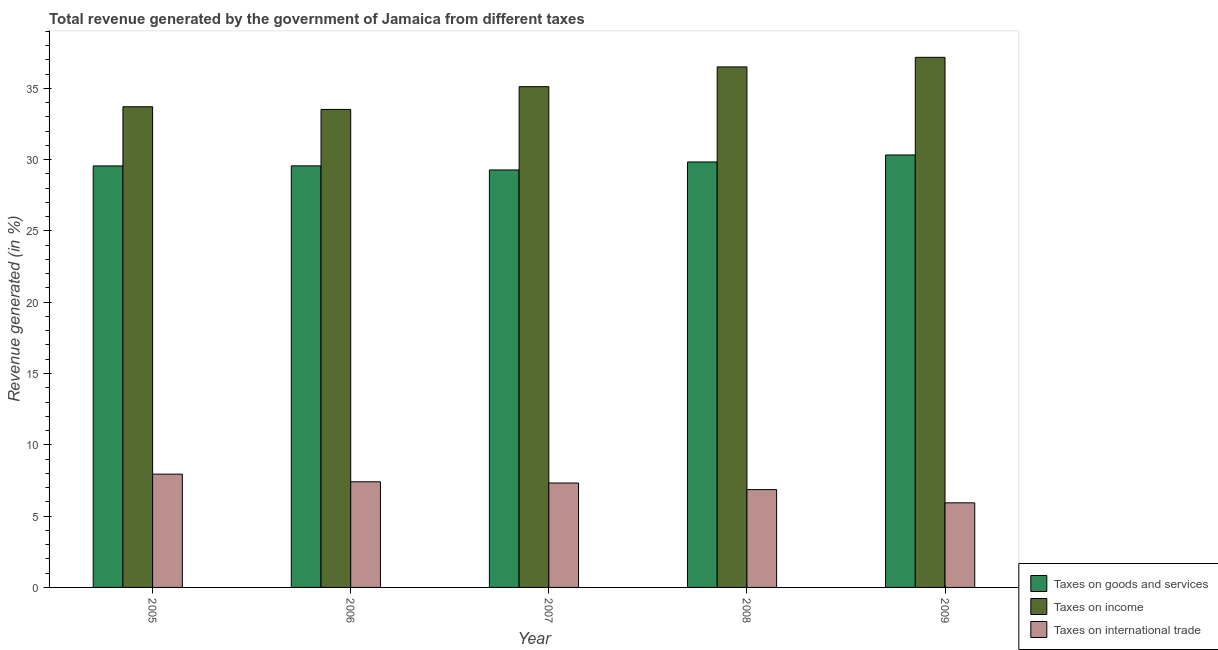How many different coloured bars are there?
Keep it short and to the point. 3. Are the number of bars per tick equal to the number of legend labels?
Give a very brief answer. Yes. Are the number of bars on each tick of the X-axis equal?
Keep it short and to the point. Yes. What is the label of the 3rd group of bars from the left?
Keep it short and to the point. 2007. What is the percentage of revenue generated by taxes on goods and services in 2009?
Offer a very short reply. 30.32. Across all years, what is the maximum percentage of revenue generated by tax on international trade?
Give a very brief answer. 7.94. Across all years, what is the minimum percentage of revenue generated by taxes on goods and services?
Your answer should be very brief. 29.27. In which year was the percentage of revenue generated by taxes on income maximum?
Your response must be concise. 2009. In which year was the percentage of revenue generated by taxes on income minimum?
Your answer should be very brief. 2006. What is the total percentage of revenue generated by taxes on income in the graph?
Your answer should be compact. 176. What is the difference between the percentage of revenue generated by tax on international trade in 2006 and that in 2007?
Your answer should be very brief. 0.08. What is the difference between the percentage of revenue generated by tax on international trade in 2007 and the percentage of revenue generated by taxes on goods and services in 2008?
Provide a succinct answer. 0.46. What is the average percentage of revenue generated by taxes on goods and services per year?
Your response must be concise. 29.71. What is the ratio of the percentage of revenue generated by taxes on goods and services in 2006 to that in 2007?
Your answer should be compact. 1.01. What is the difference between the highest and the second highest percentage of revenue generated by taxes on income?
Your answer should be very brief. 0.67. What is the difference between the highest and the lowest percentage of revenue generated by taxes on income?
Provide a succinct answer. 3.65. In how many years, is the percentage of revenue generated by taxes on goods and services greater than the average percentage of revenue generated by taxes on goods and services taken over all years?
Your response must be concise. 2. Is the sum of the percentage of revenue generated by tax on international trade in 2006 and 2007 greater than the maximum percentage of revenue generated by taxes on income across all years?
Provide a succinct answer. Yes. What does the 1st bar from the left in 2009 represents?
Ensure brevity in your answer.  Taxes on goods and services. What does the 1st bar from the right in 2005 represents?
Your response must be concise. Taxes on international trade. How many bars are there?
Your answer should be very brief. 15. Are all the bars in the graph horizontal?
Offer a very short reply. No. What is the difference between two consecutive major ticks on the Y-axis?
Offer a terse response. 5. Are the values on the major ticks of Y-axis written in scientific E-notation?
Provide a succinct answer. No. Where does the legend appear in the graph?
Ensure brevity in your answer.  Bottom right. How many legend labels are there?
Offer a terse response. 3. What is the title of the graph?
Provide a succinct answer. Total revenue generated by the government of Jamaica from different taxes. What is the label or title of the X-axis?
Keep it short and to the point. Year. What is the label or title of the Y-axis?
Offer a very short reply. Revenue generated (in %). What is the Revenue generated (in %) of Taxes on goods and services in 2005?
Give a very brief answer. 29.55. What is the Revenue generated (in %) of Taxes on income in 2005?
Ensure brevity in your answer.  33.7. What is the Revenue generated (in %) in Taxes on international trade in 2005?
Provide a short and direct response. 7.94. What is the Revenue generated (in %) in Taxes on goods and services in 2006?
Your response must be concise. 29.56. What is the Revenue generated (in %) in Taxes on income in 2006?
Keep it short and to the point. 33.52. What is the Revenue generated (in %) in Taxes on international trade in 2006?
Provide a succinct answer. 7.41. What is the Revenue generated (in %) of Taxes on goods and services in 2007?
Your response must be concise. 29.27. What is the Revenue generated (in %) of Taxes on income in 2007?
Give a very brief answer. 35.11. What is the Revenue generated (in %) in Taxes on international trade in 2007?
Make the answer very short. 7.32. What is the Revenue generated (in %) in Taxes on goods and services in 2008?
Offer a terse response. 29.83. What is the Revenue generated (in %) in Taxes on income in 2008?
Make the answer very short. 36.5. What is the Revenue generated (in %) of Taxes on international trade in 2008?
Your answer should be compact. 6.86. What is the Revenue generated (in %) in Taxes on goods and services in 2009?
Offer a terse response. 30.32. What is the Revenue generated (in %) in Taxes on income in 2009?
Make the answer very short. 37.17. What is the Revenue generated (in %) in Taxes on international trade in 2009?
Offer a very short reply. 5.93. Across all years, what is the maximum Revenue generated (in %) of Taxes on goods and services?
Offer a very short reply. 30.32. Across all years, what is the maximum Revenue generated (in %) of Taxes on income?
Your answer should be very brief. 37.17. Across all years, what is the maximum Revenue generated (in %) of Taxes on international trade?
Make the answer very short. 7.94. Across all years, what is the minimum Revenue generated (in %) in Taxes on goods and services?
Provide a short and direct response. 29.27. Across all years, what is the minimum Revenue generated (in %) in Taxes on income?
Keep it short and to the point. 33.52. Across all years, what is the minimum Revenue generated (in %) in Taxes on international trade?
Your answer should be compact. 5.93. What is the total Revenue generated (in %) in Taxes on goods and services in the graph?
Your answer should be compact. 148.54. What is the total Revenue generated (in %) of Taxes on income in the graph?
Make the answer very short. 176. What is the total Revenue generated (in %) in Taxes on international trade in the graph?
Your answer should be very brief. 35.46. What is the difference between the Revenue generated (in %) in Taxes on goods and services in 2005 and that in 2006?
Provide a succinct answer. -0. What is the difference between the Revenue generated (in %) in Taxes on income in 2005 and that in 2006?
Your answer should be very brief. 0.19. What is the difference between the Revenue generated (in %) in Taxes on international trade in 2005 and that in 2006?
Your answer should be very brief. 0.54. What is the difference between the Revenue generated (in %) of Taxes on goods and services in 2005 and that in 2007?
Give a very brief answer. 0.28. What is the difference between the Revenue generated (in %) in Taxes on income in 2005 and that in 2007?
Provide a short and direct response. -1.41. What is the difference between the Revenue generated (in %) of Taxes on international trade in 2005 and that in 2007?
Your answer should be very brief. 0.62. What is the difference between the Revenue generated (in %) of Taxes on goods and services in 2005 and that in 2008?
Offer a terse response. -0.28. What is the difference between the Revenue generated (in %) in Taxes on income in 2005 and that in 2008?
Provide a short and direct response. -2.79. What is the difference between the Revenue generated (in %) of Taxes on international trade in 2005 and that in 2008?
Keep it short and to the point. 1.09. What is the difference between the Revenue generated (in %) of Taxes on goods and services in 2005 and that in 2009?
Keep it short and to the point. -0.77. What is the difference between the Revenue generated (in %) of Taxes on income in 2005 and that in 2009?
Make the answer very short. -3.47. What is the difference between the Revenue generated (in %) in Taxes on international trade in 2005 and that in 2009?
Keep it short and to the point. 2.01. What is the difference between the Revenue generated (in %) in Taxes on goods and services in 2006 and that in 2007?
Offer a terse response. 0.28. What is the difference between the Revenue generated (in %) of Taxes on income in 2006 and that in 2007?
Offer a terse response. -1.6. What is the difference between the Revenue generated (in %) in Taxes on international trade in 2006 and that in 2007?
Give a very brief answer. 0.08. What is the difference between the Revenue generated (in %) in Taxes on goods and services in 2006 and that in 2008?
Offer a terse response. -0.28. What is the difference between the Revenue generated (in %) in Taxes on income in 2006 and that in 2008?
Give a very brief answer. -2.98. What is the difference between the Revenue generated (in %) in Taxes on international trade in 2006 and that in 2008?
Offer a very short reply. 0.55. What is the difference between the Revenue generated (in %) of Taxes on goods and services in 2006 and that in 2009?
Give a very brief answer. -0.77. What is the difference between the Revenue generated (in %) of Taxes on income in 2006 and that in 2009?
Offer a very short reply. -3.65. What is the difference between the Revenue generated (in %) of Taxes on international trade in 2006 and that in 2009?
Ensure brevity in your answer.  1.48. What is the difference between the Revenue generated (in %) in Taxes on goods and services in 2007 and that in 2008?
Provide a short and direct response. -0.56. What is the difference between the Revenue generated (in %) of Taxes on income in 2007 and that in 2008?
Your response must be concise. -1.38. What is the difference between the Revenue generated (in %) in Taxes on international trade in 2007 and that in 2008?
Offer a terse response. 0.46. What is the difference between the Revenue generated (in %) of Taxes on goods and services in 2007 and that in 2009?
Make the answer very short. -1.05. What is the difference between the Revenue generated (in %) of Taxes on income in 2007 and that in 2009?
Your answer should be compact. -2.06. What is the difference between the Revenue generated (in %) in Taxes on international trade in 2007 and that in 2009?
Your response must be concise. 1.39. What is the difference between the Revenue generated (in %) in Taxes on goods and services in 2008 and that in 2009?
Your response must be concise. -0.49. What is the difference between the Revenue generated (in %) of Taxes on income in 2008 and that in 2009?
Your answer should be compact. -0.67. What is the difference between the Revenue generated (in %) of Taxes on international trade in 2008 and that in 2009?
Your response must be concise. 0.93. What is the difference between the Revenue generated (in %) of Taxes on goods and services in 2005 and the Revenue generated (in %) of Taxes on income in 2006?
Give a very brief answer. -3.96. What is the difference between the Revenue generated (in %) of Taxes on goods and services in 2005 and the Revenue generated (in %) of Taxes on international trade in 2006?
Give a very brief answer. 22.15. What is the difference between the Revenue generated (in %) in Taxes on income in 2005 and the Revenue generated (in %) in Taxes on international trade in 2006?
Offer a terse response. 26.3. What is the difference between the Revenue generated (in %) in Taxes on goods and services in 2005 and the Revenue generated (in %) in Taxes on income in 2007?
Your answer should be compact. -5.56. What is the difference between the Revenue generated (in %) in Taxes on goods and services in 2005 and the Revenue generated (in %) in Taxes on international trade in 2007?
Keep it short and to the point. 22.23. What is the difference between the Revenue generated (in %) of Taxes on income in 2005 and the Revenue generated (in %) of Taxes on international trade in 2007?
Ensure brevity in your answer.  26.38. What is the difference between the Revenue generated (in %) of Taxes on goods and services in 2005 and the Revenue generated (in %) of Taxes on income in 2008?
Ensure brevity in your answer.  -6.94. What is the difference between the Revenue generated (in %) of Taxes on goods and services in 2005 and the Revenue generated (in %) of Taxes on international trade in 2008?
Give a very brief answer. 22.7. What is the difference between the Revenue generated (in %) of Taxes on income in 2005 and the Revenue generated (in %) of Taxes on international trade in 2008?
Keep it short and to the point. 26.84. What is the difference between the Revenue generated (in %) of Taxes on goods and services in 2005 and the Revenue generated (in %) of Taxes on income in 2009?
Ensure brevity in your answer.  -7.61. What is the difference between the Revenue generated (in %) in Taxes on goods and services in 2005 and the Revenue generated (in %) in Taxes on international trade in 2009?
Provide a short and direct response. 23.62. What is the difference between the Revenue generated (in %) of Taxes on income in 2005 and the Revenue generated (in %) of Taxes on international trade in 2009?
Offer a very short reply. 27.77. What is the difference between the Revenue generated (in %) of Taxes on goods and services in 2006 and the Revenue generated (in %) of Taxes on income in 2007?
Give a very brief answer. -5.56. What is the difference between the Revenue generated (in %) in Taxes on goods and services in 2006 and the Revenue generated (in %) in Taxes on international trade in 2007?
Offer a very short reply. 22.23. What is the difference between the Revenue generated (in %) in Taxes on income in 2006 and the Revenue generated (in %) in Taxes on international trade in 2007?
Provide a succinct answer. 26.19. What is the difference between the Revenue generated (in %) in Taxes on goods and services in 2006 and the Revenue generated (in %) in Taxes on income in 2008?
Your response must be concise. -6.94. What is the difference between the Revenue generated (in %) in Taxes on goods and services in 2006 and the Revenue generated (in %) in Taxes on international trade in 2008?
Provide a succinct answer. 22.7. What is the difference between the Revenue generated (in %) of Taxes on income in 2006 and the Revenue generated (in %) of Taxes on international trade in 2008?
Your answer should be very brief. 26.66. What is the difference between the Revenue generated (in %) of Taxes on goods and services in 2006 and the Revenue generated (in %) of Taxes on income in 2009?
Keep it short and to the point. -7.61. What is the difference between the Revenue generated (in %) of Taxes on goods and services in 2006 and the Revenue generated (in %) of Taxes on international trade in 2009?
Offer a terse response. 23.63. What is the difference between the Revenue generated (in %) in Taxes on income in 2006 and the Revenue generated (in %) in Taxes on international trade in 2009?
Make the answer very short. 27.58. What is the difference between the Revenue generated (in %) of Taxes on goods and services in 2007 and the Revenue generated (in %) of Taxes on income in 2008?
Your answer should be very brief. -7.22. What is the difference between the Revenue generated (in %) in Taxes on goods and services in 2007 and the Revenue generated (in %) in Taxes on international trade in 2008?
Offer a very short reply. 22.41. What is the difference between the Revenue generated (in %) in Taxes on income in 2007 and the Revenue generated (in %) in Taxes on international trade in 2008?
Give a very brief answer. 28.25. What is the difference between the Revenue generated (in %) of Taxes on goods and services in 2007 and the Revenue generated (in %) of Taxes on income in 2009?
Your response must be concise. -7.9. What is the difference between the Revenue generated (in %) in Taxes on goods and services in 2007 and the Revenue generated (in %) in Taxes on international trade in 2009?
Give a very brief answer. 23.34. What is the difference between the Revenue generated (in %) in Taxes on income in 2007 and the Revenue generated (in %) in Taxes on international trade in 2009?
Provide a short and direct response. 29.18. What is the difference between the Revenue generated (in %) in Taxes on goods and services in 2008 and the Revenue generated (in %) in Taxes on income in 2009?
Offer a terse response. -7.34. What is the difference between the Revenue generated (in %) of Taxes on goods and services in 2008 and the Revenue generated (in %) of Taxes on international trade in 2009?
Your answer should be very brief. 23.9. What is the difference between the Revenue generated (in %) of Taxes on income in 2008 and the Revenue generated (in %) of Taxes on international trade in 2009?
Your answer should be compact. 30.57. What is the average Revenue generated (in %) of Taxes on goods and services per year?
Provide a short and direct response. 29.71. What is the average Revenue generated (in %) of Taxes on income per year?
Keep it short and to the point. 35.2. What is the average Revenue generated (in %) in Taxes on international trade per year?
Ensure brevity in your answer.  7.09. In the year 2005, what is the difference between the Revenue generated (in %) of Taxes on goods and services and Revenue generated (in %) of Taxes on income?
Offer a terse response. -4.15. In the year 2005, what is the difference between the Revenue generated (in %) of Taxes on goods and services and Revenue generated (in %) of Taxes on international trade?
Provide a short and direct response. 21.61. In the year 2005, what is the difference between the Revenue generated (in %) of Taxes on income and Revenue generated (in %) of Taxes on international trade?
Provide a short and direct response. 25.76. In the year 2006, what is the difference between the Revenue generated (in %) of Taxes on goods and services and Revenue generated (in %) of Taxes on income?
Give a very brief answer. -3.96. In the year 2006, what is the difference between the Revenue generated (in %) in Taxes on goods and services and Revenue generated (in %) in Taxes on international trade?
Give a very brief answer. 22.15. In the year 2006, what is the difference between the Revenue generated (in %) in Taxes on income and Revenue generated (in %) in Taxes on international trade?
Provide a succinct answer. 26.11. In the year 2007, what is the difference between the Revenue generated (in %) in Taxes on goods and services and Revenue generated (in %) in Taxes on income?
Keep it short and to the point. -5.84. In the year 2007, what is the difference between the Revenue generated (in %) in Taxes on goods and services and Revenue generated (in %) in Taxes on international trade?
Offer a very short reply. 21.95. In the year 2007, what is the difference between the Revenue generated (in %) in Taxes on income and Revenue generated (in %) in Taxes on international trade?
Ensure brevity in your answer.  27.79. In the year 2008, what is the difference between the Revenue generated (in %) in Taxes on goods and services and Revenue generated (in %) in Taxes on income?
Give a very brief answer. -6.66. In the year 2008, what is the difference between the Revenue generated (in %) of Taxes on goods and services and Revenue generated (in %) of Taxes on international trade?
Keep it short and to the point. 22.97. In the year 2008, what is the difference between the Revenue generated (in %) in Taxes on income and Revenue generated (in %) in Taxes on international trade?
Provide a short and direct response. 29.64. In the year 2009, what is the difference between the Revenue generated (in %) in Taxes on goods and services and Revenue generated (in %) in Taxes on income?
Offer a very short reply. -6.85. In the year 2009, what is the difference between the Revenue generated (in %) in Taxes on goods and services and Revenue generated (in %) in Taxes on international trade?
Give a very brief answer. 24.39. In the year 2009, what is the difference between the Revenue generated (in %) in Taxes on income and Revenue generated (in %) in Taxes on international trade?
Ensure brevity in your answer.  31.24. What is the ratio of the Revenue generated (in %) in Taxes on income in 2005 to that in 2006?
Offer a very short reply. 1.01. What is the ratio of the Revenue generated (in %) in Taxes on international trade in 2005 to that in 2006?
Ensure brevity in your answer.  1.07. What is the ratio of the Revenue generated (in %) in Taxes on goods and services in 2005 to that in 2007?
Give a very brief answer. 1.01. What is the ratio of the Revenue generated (in %) of Taxes on income in 2005 to that in 2007?
Give a very brief answer. 0.96. What is the ratio of the Revenue generated (in %) in Taxes on international trade in 2005 to that in 2007?
Offer a terse response. 1.08. What is the ratio of the Revenue generated (in %) in Taxes on goods and services in 2005 to that in 2008?
Your answer should be very brief. 0.99. What is the ratio of the Revenue generated (in %) in Taxes on income in 2005 to that in 2008?
Your response must be concise. 0.92. What is the ratio of the Revenue generated (in %) of Taxes on international trade in 2005 to that in 2008?
Provide a short and direct response. 1.16. What is the ratio of the Revenue generated (in %) of Taxes on goods and services in 2005 to that in 2009?
Give a very brief answer. 0.97. What is the ratio of the Revenue generated (in %) of Taxes on income in 2005 to that in 2009?
Your answer should be very brief. 0.91. What is the ratio of the Revenue generated (in %) in Taxes on international trade in 2005 to that in 2009?
Keep it short and to the point. 1.34. What is the ratio of the Revenue generated (in %) of Taxes on goods and services in 2006 to that in 2007?
Offer a terse response. 1.01. What is the ratio of the Revenue generated (in %) of Taxes on income in 2006 to that in 2007?
Provide a succinct answer. 0.95. What is the ratio of the Revenue generated (in %) in Taxes on international trade in 2006 to that in 2007?
Make the answer very short. 1.01. What is the ratio of the Revenue generated (in %) of Taxes on goods and services in 2006 to that in 2008?
Give a very brief answer. 0.99. What is the ratio of the Revenue generated (in %) of Taxes on income in 2006 to that in 2008?
Offer a very short reply. 0.92. What is the ratio of the Revenue generated (in %) of Taxes on goods and services in 2006 to that in 2009?
Offer a very short reply. 0.97. What is the ratio of the Revenue generated (in %) of Taxes on income in 2006 to that in 2009?
Provide a succinct answer. 0.9. What is the ratio of the Revenue generated (in %) of Taxes on international trade in 2006 to that in 2009?
Your response must be concise. 1.25. What is the ratio of the Revenue generated (in %) of Taxes on goods and services in 2007 to that in 2008?
Your answer should be very brief. 0.98. What is the ratio of the Revenue generated (in %) in Taxes on income in 2007 to that in 2008?
Keep it short and to the point. 0.96. What is the ratio of the Revenue generated (in %) in Taxes on international trade in 2007 to that in 2008?
Provide a short and direct response. 1.07. What is the ratio of the Revenue generated (in %) of Taxes on goods and services in 2007 to that in 2009?
Your answer should be very brief. 0.97. What is the ratio of the Revenue generated (in %) of Taxes on income in 2007 to that in 2009?
Ensure brevity in your answer.  0.94. What is the ratio of the Revenue generated (in %) of Taxes on international trade in 2007 to that in 2009?
Your response must be concise. 1.23. What is the ratio of the Revenue generated (in %) in Taxes on goods and services in 2008 to that in 2009?
Give a very brief answer. 0.98. What is the ratio of the Revenue generated (in %) of Taxes on income in 2008 to that in 2009?
Your answer should be very brief. 0.98. What is the ratio of the Revenue generated (in %) of Taxes on international trade in 2008 to that in 2009?
Your answer should be compact. 1.16. What is the difference between the highest and the second highest Revenue generated (in %) of Taxes on goods and services?
Provide a succinct answer. 0.49. What is the difference between the highest and the second highest Revenue generated (in %) in Taxes on income?
Give a very brief answer. 0.67. What is the difference between the highest and the second highest Revenue generated (in %) of Taxes on international trade?
Offer a terse response. 0.54. What is the difference between the highest and the lowest Revenue generated (in %) in Taxes on goods and services?
Give a very brief answer. 1.05. What is the difference between the highest and the lowest Revenue generated (in %) of Taxes on income?
Your answer should be very brief. 3.65. What is the difference between the highest and the lowest Revenue generated (in %) of Taxes on international trade?
Keep it short and to the point. 2.01. 